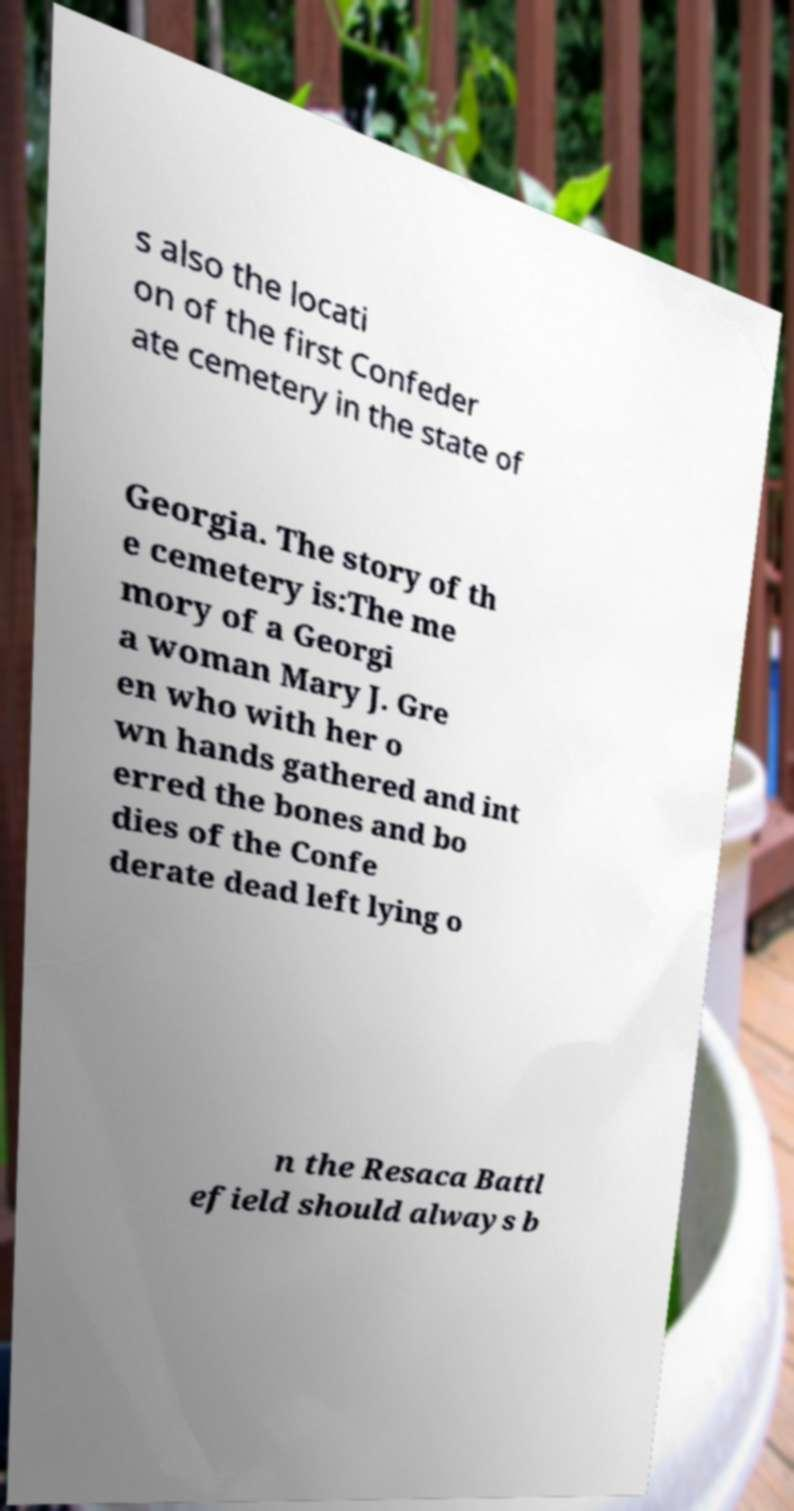Could you assist in decoding the text presented in this image and type it out clearly? s also the locati on of the first Confeder ate cemetery in the state of Georgia. The story of th e cemetery is:The me mory of a Georgi a woman Mary J. Gre en who with her o wn hands gathered and int erred the bones and bo dies of the Confe derate dead left lying o n the Resaca Battl efield should always b 